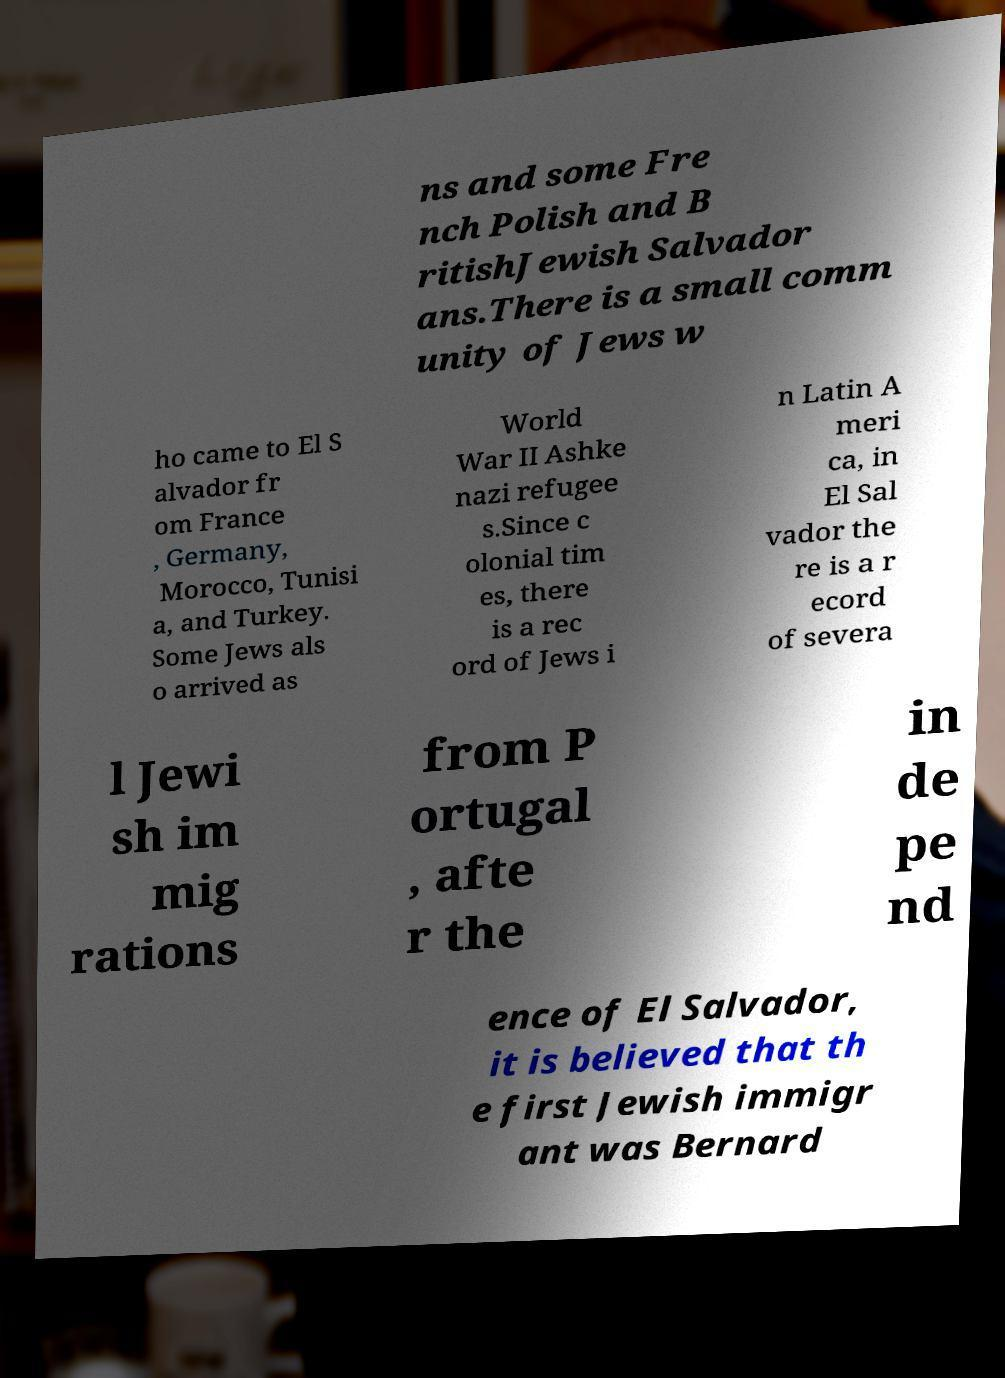Please read and relay the text visible in this image. What does it say? ns and some Fre nch Polish and B ritishJewish Salvador ans.There is a small comm unity of Jews w ho came to El S alvador fr om France , Germany, Morocco, Tunisi a, and Turkey. Some Jews als o arrived as World War II Ashke nazi refugee s.Since c olonial tim es, there is a rec ord of Jews i n Latin A meri ca, in El Sal vador the re is a r ecord of severa l Jewi sh im mig rations from P ortugal , afte r the in de pe nd ence of El Salvador, it is believed that th e first Jewish immigr ant was Bernard 